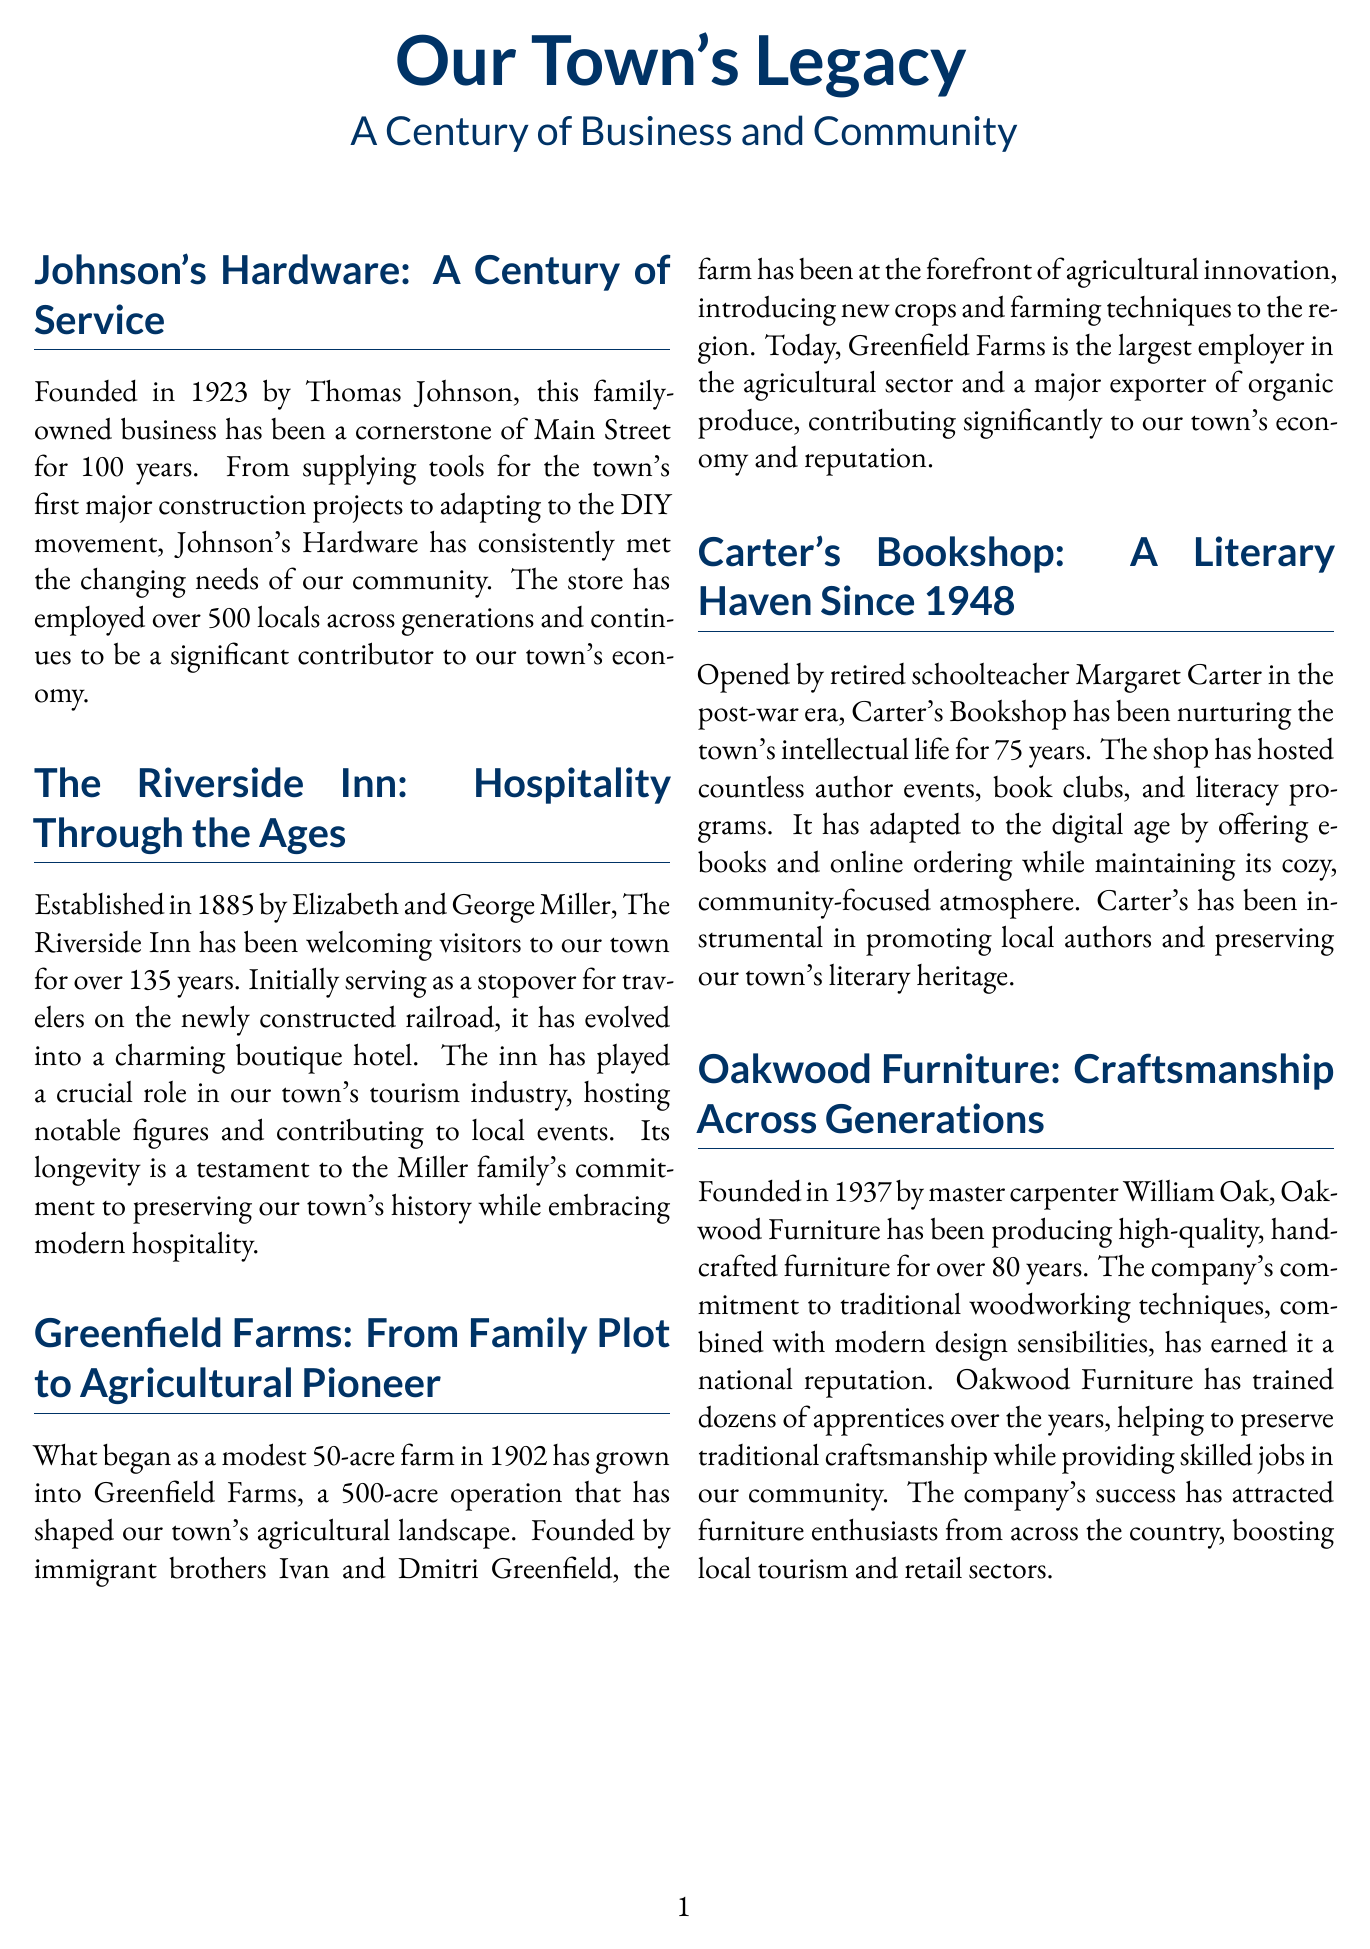What year was Johnson's Hardware founded? The document states that Johnson's Hardware was founded in 1923.
Answer: 1923 How many years has The Riverside Inn been operating? The document indicates that The Riverside Inn has been operating for over 135 years since its establishment in 1885.
Answer: 135 years Who founded Greenfield Farms? The document mentions that Greenfield Farms was founded by immigrant brothers Ivan and Dmitri Greenfield.
Answer: Ivan and Dmitri Greenfield What has Oakwood Furniture been known for? The document highlights that Oakwood Furniture has been producing high-quality, handcrafted furniture for over 80 years.
Answer: High-quality, handcrafted furniture How many locals has Johnson's Hardware employed across generations? The document states that Johnson's Hardware has employed over 500 locals.
Answer: Over 500 What significant role does The Riverside Inn play in the town? The document describes The Riverside Inn's crucial role in the town's tourism industry.
Answer: Tourism industry What is the primary focus of Carter's Bookshop? The document explains that Carter's Bookshop has been nurturing the town's intellectual life.
Answer: Intellectual life What did Greenfield Farms introduce to the region? The document says that Greenfield Farms introduced new crops and farming techniques to the region.
Answer: New crops and farming techniques What legacy does Oakwood Furniture preserve? The document notes that Oakwood Furniture helps to preserve traditional craftsmanship.
Answer: Traditional craftsmanship 